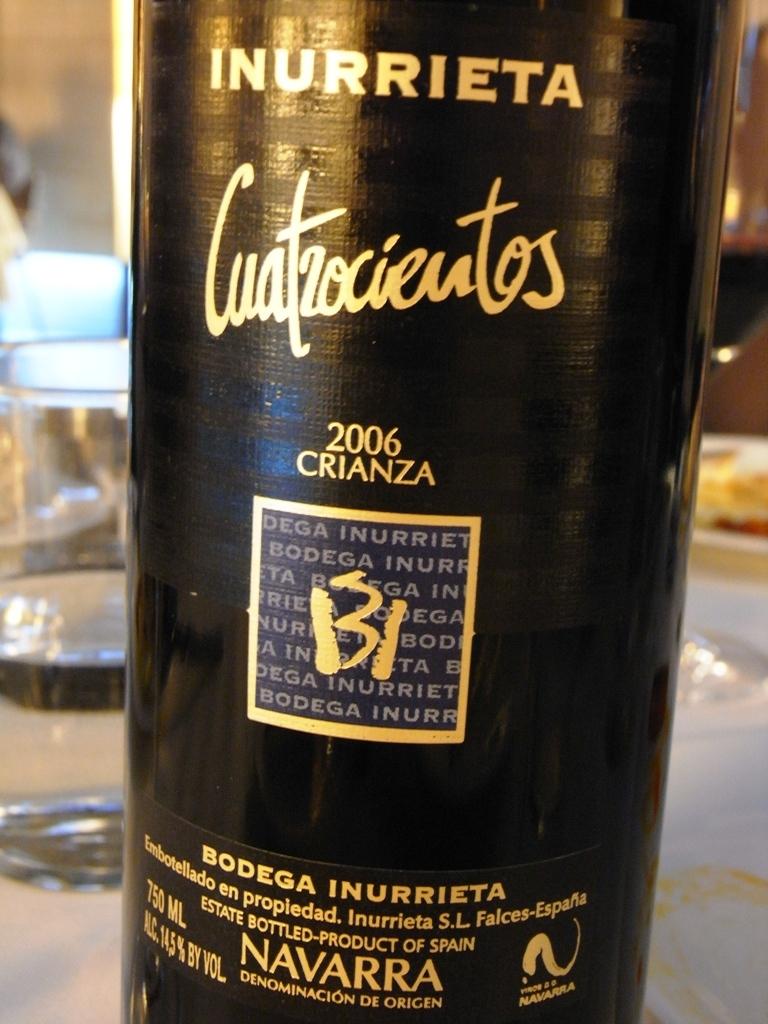What is the brand of the wine?
Make the answer very short. Inurrieta. 